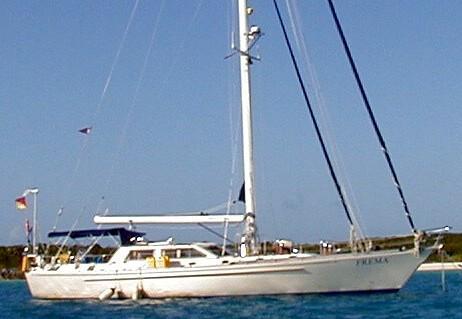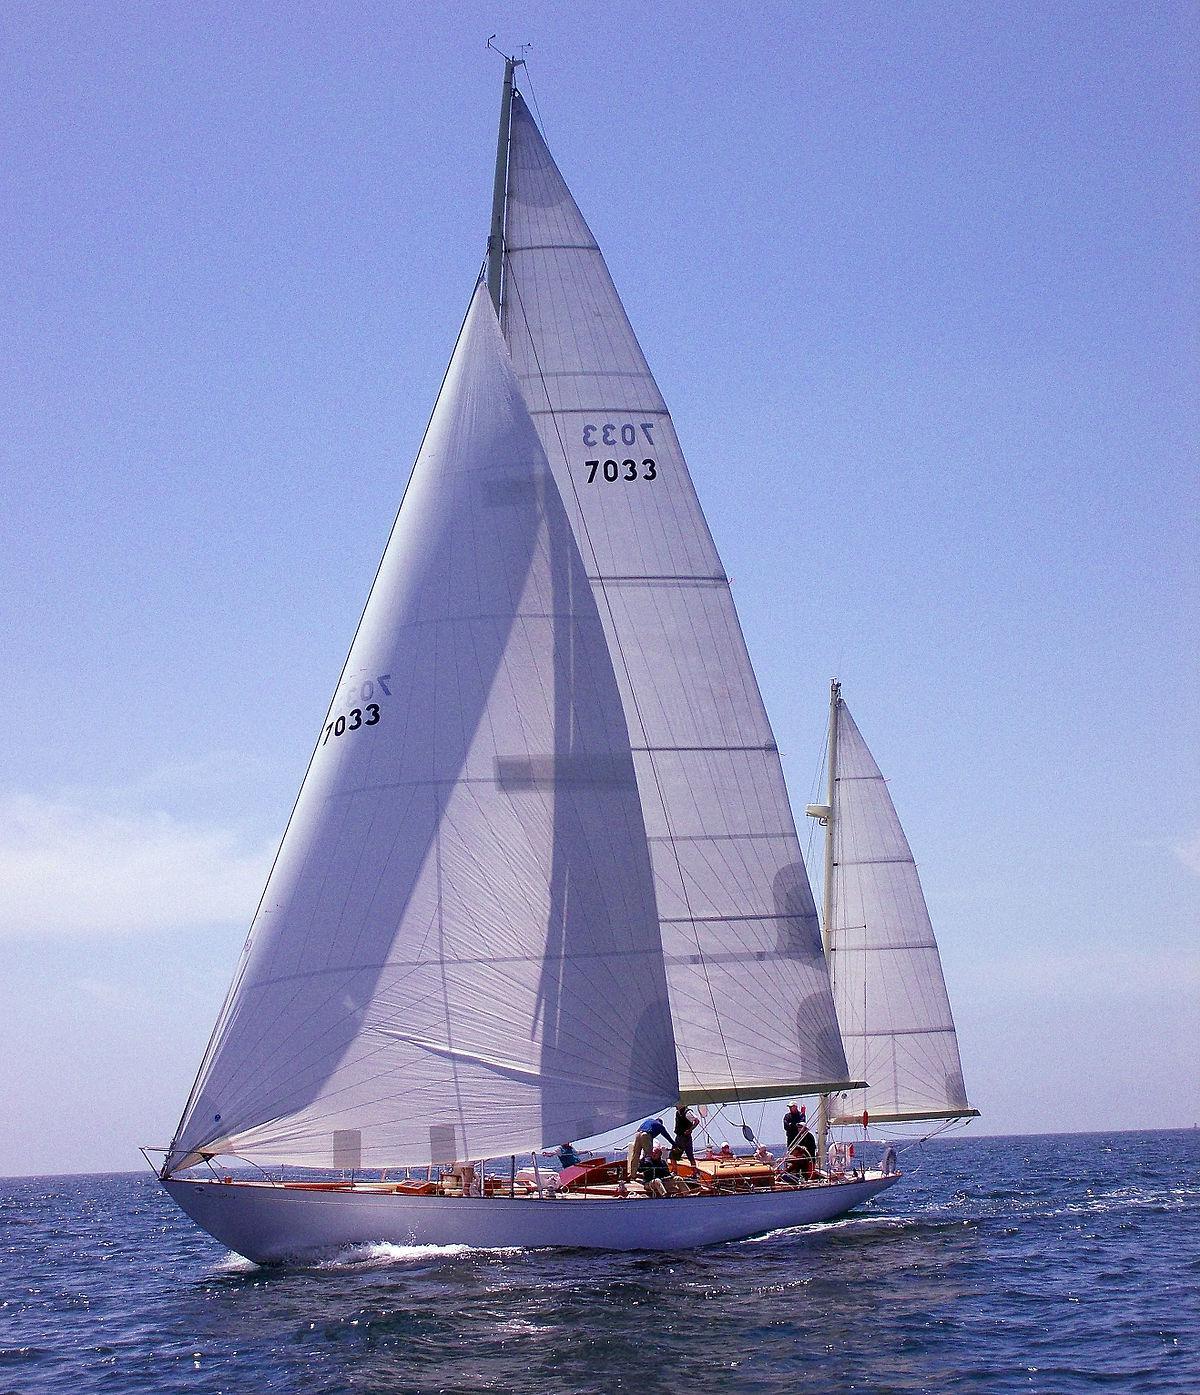The first image is the image on the left, the second image is the image on the right. Given the left and right images, does the statement "All sailboats have at least four sails." hold true? Answer yes or no. No. The first image is the image on the left, the second image is the image on the right. Evaluate the accuracy of this statement regarding the images: "The boat on the right has more than three visible sails unfurled.". Is it true? Answer yes or no. No. 